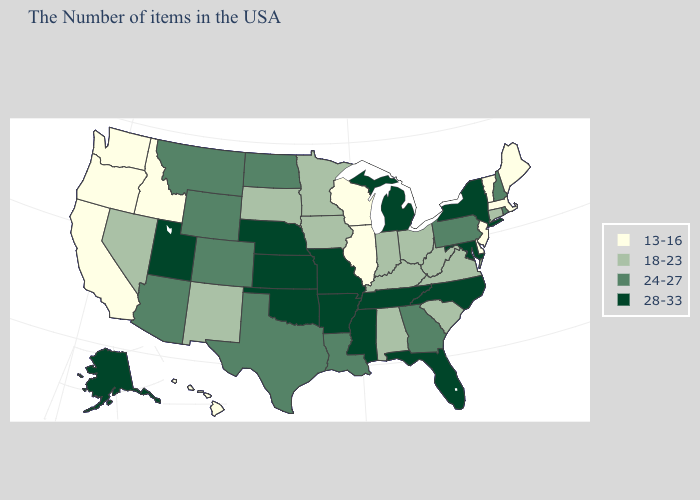Does Maine have a lower value than New York?
Short answer required. Yes. Among the states that border New Mexico , which have the lowest value?
Short answer required. Texas, Colorado, Arizona. Among the states that border Iowa , does Wisconsin have the lowest value?
Write a very short answer. Yes. Does Illinois have the highest value in the MidWest?
Answer briefly. No. What is the value of Nevada?
Answer briefly. 18-23. What is the lowest value in the USA?
Quick response, please. 13-16. Which states have the lowest value in the USA?
Short answer required. Maine, Massachusetts, Vermont, New Jersey, Delaware, Wisconsin, Illinois, Idaho, California, Washington, Oregon, Hawaii. Is the legend a continuous bar?
Concise answer only. No. Name the states that have a value in the range 18-23?
Quick response, please. Connecticut, Virginia, South Carolina, West Virginia, Ohio, Kentucky, Indiana, Alabama, Minnesota, Iowa, South Dakota, New Mexico, Nevada. What is the value of Delaware?
Answer briefly. 13-16. Does Oklahoma have the lowest value in the South?
Write a very short answer. No. Among the states that border Georgia , does North Carolina have the highest value?
Give a very brief answer. Yes. Name the states that have a value in the range 13-16?
Short answer required. Maine, Massachusetts, Vermont, New Jersey, Delaware, Wisconsin, Illinois, Idaho, California, Washington, Oregon, Hawaii. What is the value of Arizona?
Quick response, please. 24-27. 